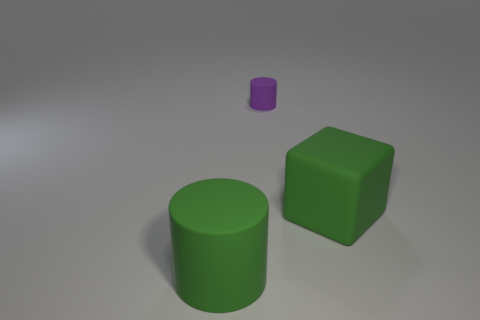There is a green rubber thing in front of the green thing that is on the right side of the purple matte cylinder; is there a big green rubber cube that is on the left side of it?
Provide a succinct answer. No. How many green rubber cylinders are the same size as the green matte cube?
Make the answer very short. 1. There is a green rubber cube on the right side of the purple rubber object; does it have the same size as the thing that is to the left of the small rubber cylinder?
Ensure brevity in your answer.  Yes. The matte object that is on the right side of the large rubber cylinder and in front of the purple matte cylinder has what shape?
Provide a succinct answer. Cube. Is there a big rubber ball of the same color as the block?
Ensure brevity in your answer.  No. Is there a small brown sphere?
Provide a short and direct response. No. What is the color of the large thing behind the green rubber cylinder?
Offer a terse response. Green. Does the green matte cube have the same size as the green matte thing that is left of the big rubber cube?
Ensure brevity in your answer.  Yes. There is a matte object that is to the left of the big green rubber block and in front of the small cylinder; how big is it?
Make the answer very short. Large. Are there any big green objects made of the same material as the tiny purple object?
Give a very brief answer. Yes. 